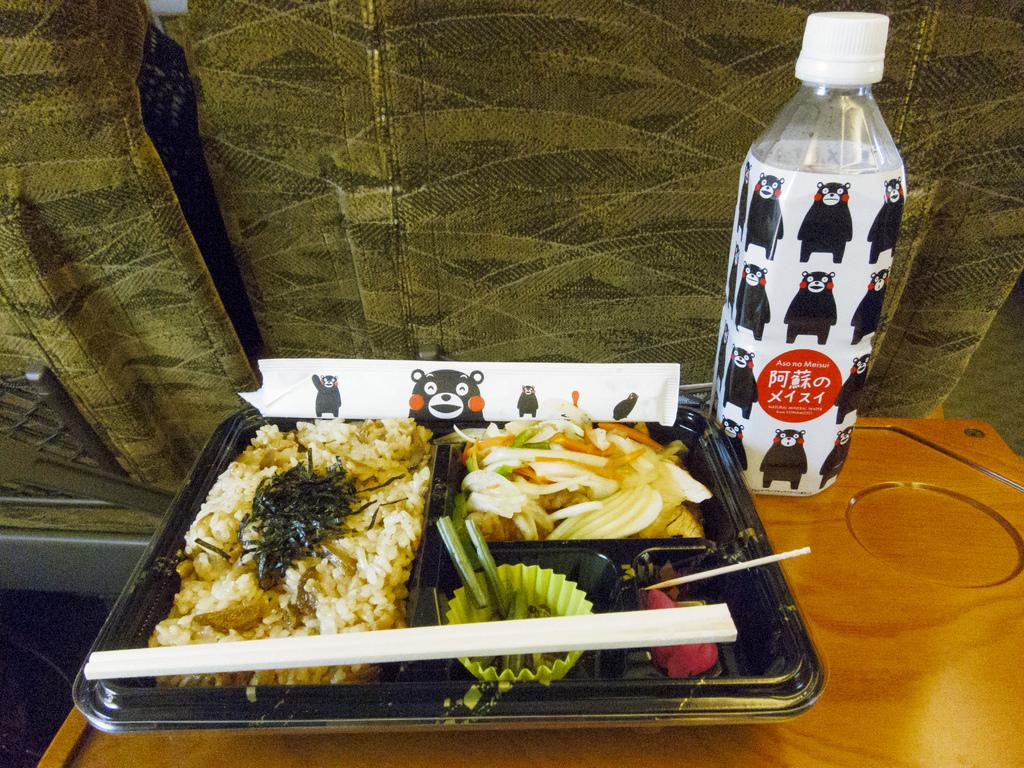<image>
Create a compact narrative representing the image presented. A tray filled with various types of food and a water bottle next to it 